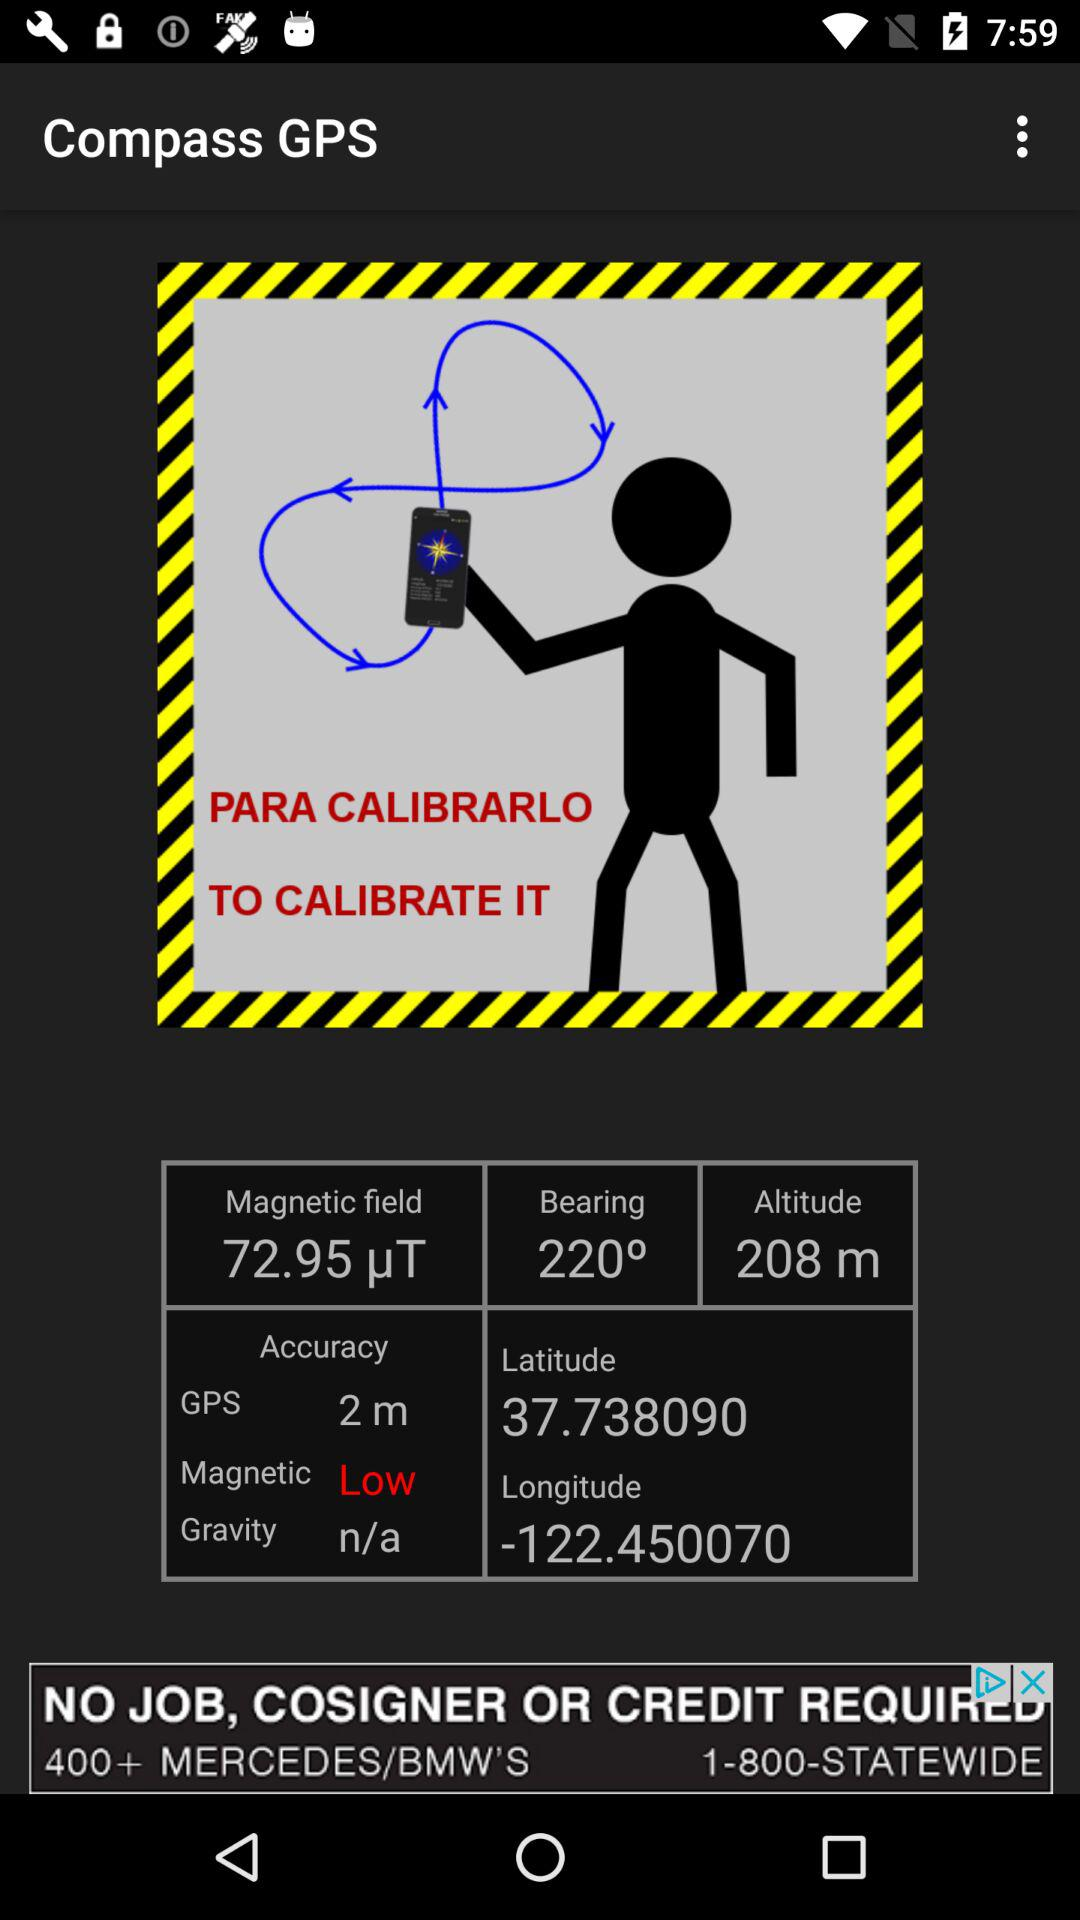What is the longitude? The longitude is -122.450061. 